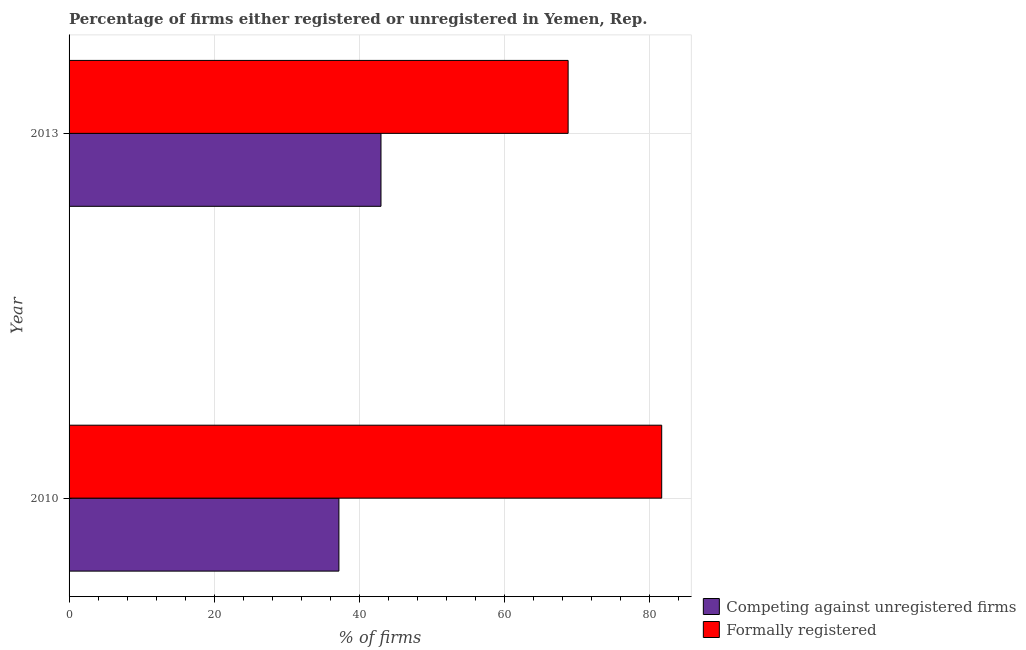How many groups of bars are there?
Give a very brief answer. 2. Are the number of bars per tick equal to the number of legend labels?
Provide a succinct answer. Yes. How many bars are there on the 1st tick from the top?
Offer a terse response. 2. What is the label of the 2nd group of bars from the top?
Your response must be concise. 2010. What is the percentage of formally registered firms in 2010?
Keep it short and to the point. 81.7. Across all years, what is the maximum percentage of formally registered firms?
Offer a terse response. 81.7. Across all years, what is the minimum percentage of formally registered firms?
Keep it short and to the point. 68.8. In which year was the percentage of formally registered firms maximum?
Give a very brief answer. 2010. What is the total percentage of registered firms in the graph?
Offer a terse response. 80.2. What is the difference between the percentage of formally registered firms in 2010 and that in 2013?
Keep it short and to the point. 12.9. What is the difference between the percentage of registered firms in 2010 and the percentage of formally registered firms in 2013?
Offer a terse response. -31.6. What is the average percentage of registered firms per year?
Your answer should be compact. 40.1. In the year 2013, what is the difference between the percentage of registered firms and percentage of formally registered firms?
Your answer should be compact. -25.8. In how many years, is the percentage of registered firms greater than 64 %?
Your response must be concise. 0. What is the ratio of the percentage of formally registered firms in 2010 to that in 2013?
Offer a very short reply. 1.19. Is the difference between the percentage of registered firms in 2010 and 2013 greater than the difference between the percentage of formally registered firms in 2010 and 2013?
Offer a very short reply. No. In how many years, is the percentage of formally registered firms greater than the average percentage of formally registered firms taken over all years?
Keep it short and to the point. 1. What does the 2nd bar from the top in 2010 represents?
Give a very brief answer. Competing against unregistered firms. What does the 2nd bar from the bottom in 2010 represents?
Provide a succinct answer. Formally registered. Are all the bars in the graph horizontal?
Provide a short and direct response. Yes. How many years are there in the graph?
Ensure brevity in your answer.  2. What is the difference between two consecutive major ticks on the X-axis?
Offer a terse response. 20. Are the values on the major ticks of X-axis written in scientific E-notation?
Your response must be concise. No. Does the graph contain any zero values?
Provide a short and direct response. No. How many legend labels are there?
Offer a very short reply. 2. What is the title of the graph?
Your response must be concise. Percentage of firms either registered or unregistered in Yemen, Rep. Does "From World Bank" appear as one of the legend labels in the graph?
Your response must be concise. No. What is the label or title of the X-axis?
Ensure brevity in your answer.  % of firms. What is the % of firms of Competing against unregistered firms in 2010?
Offer a very short reply. 37.2. What is the % of firms in Formally registered in 2010?
Offer a very short reply. 81.7. What is the % of firms in Formally registered in 2013?
Provide a short and direct response. 68.8. Across all years, what is the maximum % of firms of Competing against unregistered firms?
Keep it short and to the point. 43. Across all years, what is the maximum % of firms of Formally registered?
Your answer should be compact. 81.7. Across all years, what is the minimum % of firms in Competing against unregistered firms?
Your answer should be compact. 37.2. Across all years, what is the minimum % of firms of Formally registered?
Provide a short and direct response. 68.8. What is the total % of firms in Competing against unregistered firms in the graph?
Offer a terse response. 80.2. What is the total % of firms in Formally registered in the graph?
Give a very brief answer. 150.5. What is the difference between the % of firms in Competing against unregistered firms in 2010 and that in 2013?
Give a very brief answer. -5.8. What is the difference between the % of firms in Competing against unregistered firms in 2010 and the % of firms in Formally registered in 2013?
Provide a short and direct response. -31.6. What is the average % of firms of Competing against unregistered firms per year?
Provide a succinct answer. 40.1. What is the average % of firms in Formally registered per year?
Provide a succinct answer. 75.25. In the year 2010, what is the difference between the % of firms of Competing against unregistered firms and % of firms of Formally registered?
Ensure brevity in your answer.  -44.5. In the year 2013, what is the difference between the % of firms of Competing against unregistered firms and % of firms of Formally registered?
Provide a succinct answer. -25.8. What is the ratio of the % of firms in Competing against unregistered firms in 2010 to that in 2013?
Provide a short and direct response. 0.87. What is the ratio of the % of firms of Formally registered in 2010 to that in 2013?
Your answer should be very brief. 1.19. What is the difference between the highest and the second highest % of firms of Competing against unregistered firms?
Your answer should be very brief. 5.8. What is the difference between the highest and the second highest % of firms of Formally registered?
Your answer should be very brief. 12.9. 